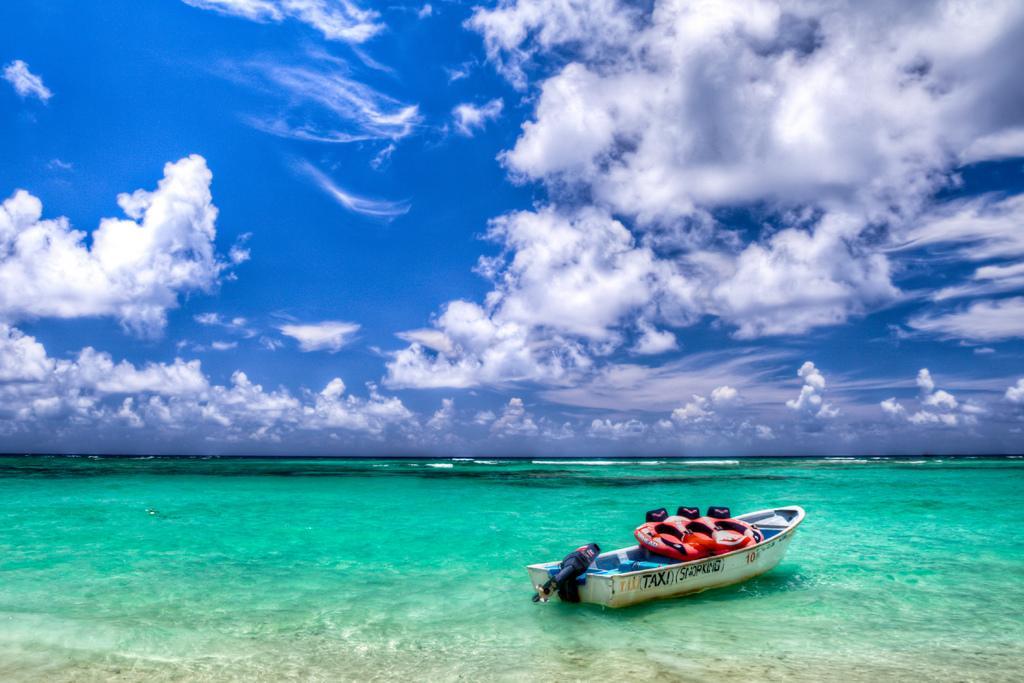How would you summarize this image in a sentence or two? In this image we can see a boat on the water. In the background there is sky with clouds. 